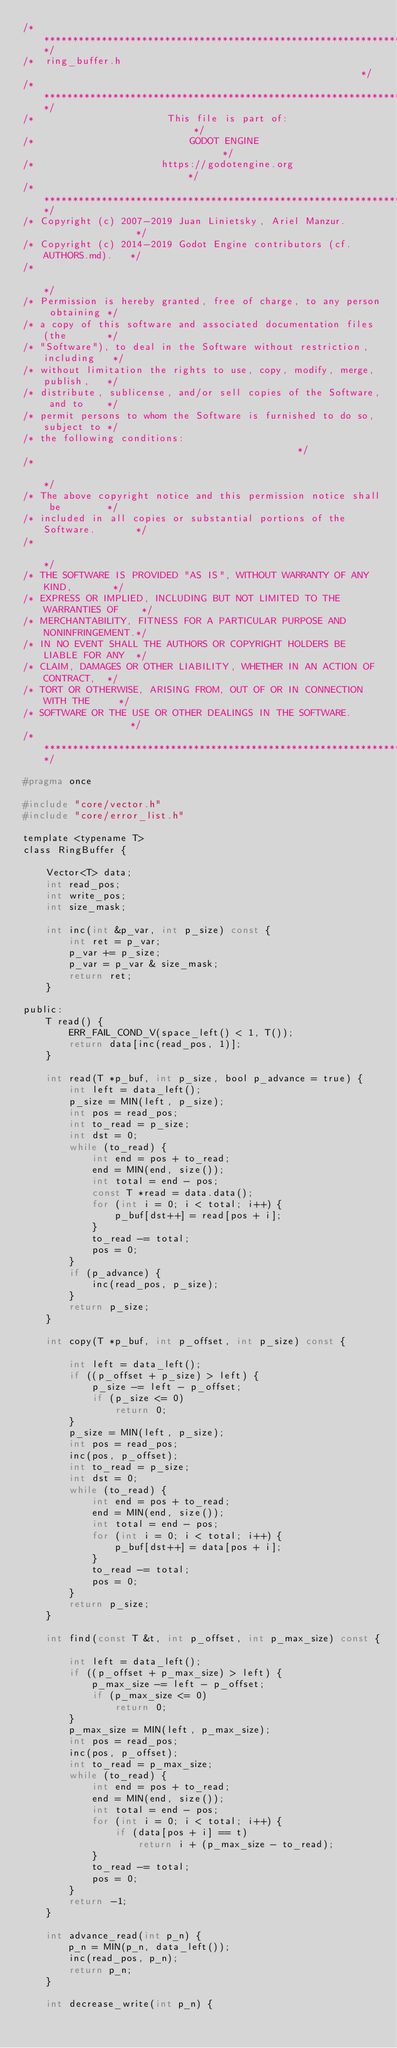Convert code to text. <code><loc_0><loc_0><loc_500><loc_500><_C_>/*************************************************************************/
/*  ring_buffer.h                                                        */
/*************************************************************************/
/*                       This file is part of:                           */
/*                           GODOT ENGINE                                */
/*                      https://godotengine.org                          */
/*************************************************************************/
/* Copyright (c) 2007-2019 Juan Linietsky, Ariel Manzur.                 */
/* Copyright (c) 2014-2019 Godot Engine contributors (cf. AUTHORS.md).   */
/*                                                                       */
/* Permission is hereby granted, free of charge, to any person obtaining */
/* a copy of this software and associated documentation files (the       */
/* "Software"), to deal in the Software without restriction, including   */
/* without limitation the rights to use, copy, modify, merge, publish,   */
/* distribute, sublicense, and/or sell copies of the Software, and to    */
/* permit persons to whom the Software is furnished to do so, subject to */
/* the following conditions:                                             */
/*                                                                       */
/* The above copyright notice and this permission notice shall be        */
/* included in all copies or substantial portions of the Software.       */
/*                                                                       */
/* THE SOFTWARE IS PROVIDED "AS IS", WITHOUT WARRANTY OF ANY KIND,       */
/* EXPRESS OR IMPLIED, INCLUDING BUT NOT LIMITED TO THE WARRANTIES OF    */
/* MERCHANTABILITY, FITNESS FOR A PARTICULAR PURPOSE AND NONINFRINGEMENT.*/
/* IN NO EVENT SHALL THE AUTHORS OR COPYRIGHT HOLDERS BE LIABLE FOR ANY  */
/* CLAIM, DAMAGES OR OTHER LIABILITY, WHETHER IN AN ACTION OF CONTRACT,  */
/* TORT OR OTHERWISE, ARISING FROM, OUT OF OR IN CONNECTION WITH THE     */
/* SOFTWARE OR THE USE OR OTHER DEALINGS IN THE SOFTWARE.                */
/*************************************************************************/

#pragma once

#include "core/vector.h"
#include "core/error_list.h"

template <typename T>
class RingBuffer {

    Vector<T> data;
    int read_pos;
    int write_pos;
    int size_mask;

    int inc(int &p_var, int p_size) const {
        int ret = p_var;
        p_var += p_size;
        p_var = p_var & size_mask;
        return ret;
    }

public:
    T read() {
        ERR_FAIL_COND_V(space_left() < 1, T());
        return data[inc(read_pos, 1)];
    }

    int read(T *p_buf, int p_size, bool p_advance = true) {
        int left = data_left();
        p_size = MIN(left, p_size);
        int pos = read_pos;
        int to_read = p_size;
        int dst = 0;
        while (to_read) {
            int end = pos + to_read;
            end = MIN(end, size());
            int total = end - pos;
            const T *read = data.data();
            for (int i = 0; i < total; i++) {
                p_buf[dst++] = read[pos + i];
            }
            to_read -= total;
            pos = 0;
        }
        if (p_advance) {
            inc(read_pos, p_size);
        }
        return p_size;
    }

    int copy(T *p_buf, int p_offset, int p_size) const {

        int left = data_left();
        if ((p_offset + p_size) > left) {
            p_size -= left - p_offset;
            if (p_size <= 0)
                return 0;
        }
        p_size = MIN(left, p_size);
        int pos = read_pos;
        inc(pos, p_offset);
        int to_read = p_size;
        int dst = 0;
        while (to_read) {
            int end = pos + to_read;
            end = MIN(end, size());
            int total = end - pos;
            for (int i = 0; i < total; i++) {
                p_buf[dst++] = data[pos + i];
            }
            to_read -= total;
            pos = 0;
        }
        return p_size;
    }

    int find(const T &t, int p_offset, int p_max_size) const {

        int left = data_left();
        if ((p_offset + p_max_size) > left) {
            p_max_size -= left - p_offset;
            if (p_max_size <= 0)
                return 0;
        }
        p_max_size = MIN(left, p_max_size);
        int pos = read_pos;
        inc(pos, p_offset);
        int to_read = p_max_size;
        while (to_read) {
            int end = pos + to_read;
            end = MIN(end, size());
            int total = end - pos;
            for (int i = 0; i < total; i++) {
                if (data[pos + i] == t)
                    return i + (p_max_size - to_read);
            }
            to_read -= total;
            pos = 0;
        }
        return -1;
    }

    int advance_read(int p_n) {
        p_n = MIN(p_n, data_left());
        inc(read_pos, p_n);
        return p_n;
    }

    int decrease_write(int p_n) {</code> 